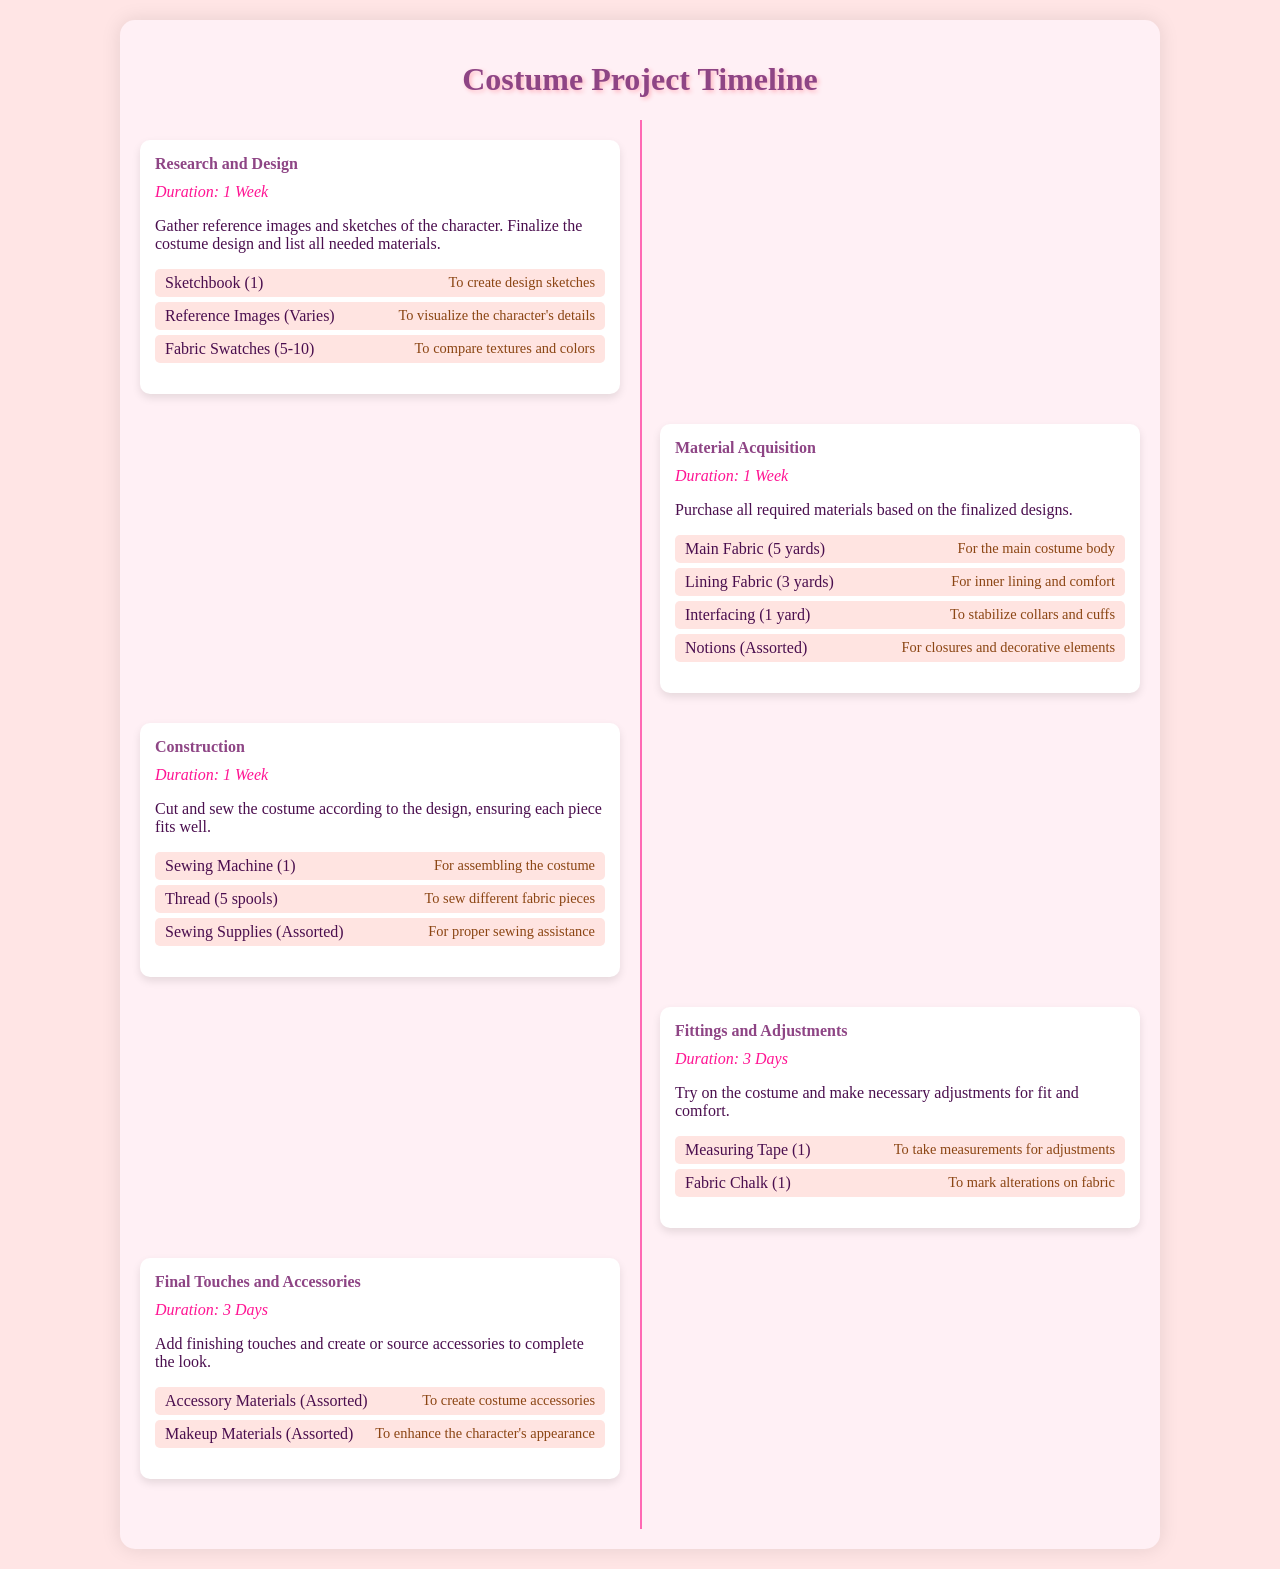what is the duration of the Research and Design phase? The duration is clearly stated in the document as 1 Week.
Answer: 1 Week how many yards of Main Fabric are required? The document specifies that 5 yards of Main Fabric are needed for the costume body.
Answer: 5 yards what materials are listed for Fittings and Adjustments? The document lists a Measuring Tape and Fabric Chalk as the materials needed for this phase.
Answer: Measuring Tape, Fabric Chalk how many days are allocated for Final Touches and Accessories? The document mentions that 3 Days are allocated for this phase.
Answer: 3 Days what is the purpose of Fabric Swatches? The purpose of Fabric Swatches is outlined in the document as comparing textures and colors.
Answer: To compare textures and colors which phase requires a Sewing Machine? The Construction phase requires a Sewing Machine for assembling the costume.
Answer: Construction how many spools of Thread are needed? The document lists that 5 spools of Thread are required for sewing different fabric pieces.
Answer: 5 spools what type of materials are used to enhance the character's appearance? The document states that Makeup Materials are used to enhance the character's appearance.
Answer: Makeup Materials what is the total duration for the Construction phase? The total duration for the Construction phase is set as 1 Week according to the document.
Answer: 1 Week 